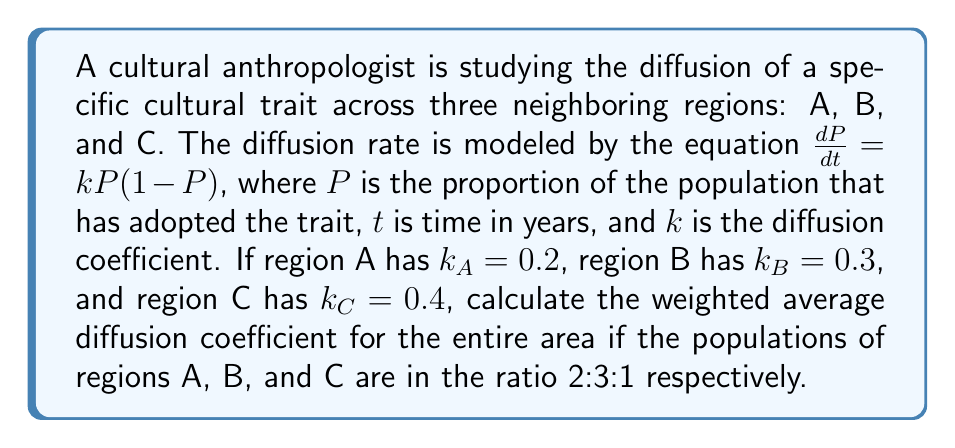Can you answer this question? To solve this problem, we need to follow these steps:

1) First, we need to understand that the weighted average will take into account the population sizes of each region. The general formula for a weighted average is:

   $$\text{Weighted Average} = \frac{\sum (\text{Value} \times \text{Weight})}{\sum \text{Weights}}$$

2) In this case, the values are the diffusion coefficients $(k)$, and the weights are the population ratios.

3) Let's assign the weights:
   Region A: 2
   Region B: 3
   Region C: 1

4) Now, let's calculate the sum of (value × weight) for each region:
   Region A: $0.2 \times 2 = 0.4$
   Region B: $0.3 \times 3 = 0.9$
   Region C: $0.4 \times 1 = 0.4$

5) Sum these values:
   $0.4 + 0.9 + 0.4 = 1.7$

6) Now, sum the weights:
   $2 + 3 + 1 = 6$

7) Finally, divide the sum of (value × weight) by the sum of weights:
   $$\text{Weighted Average } k = \frac{1.7}{6} \approx 0.2833$$

Therefore, the weighted average diffusion coefficient for the entire area is approximately 0.2833.
Answer: 0.2833 